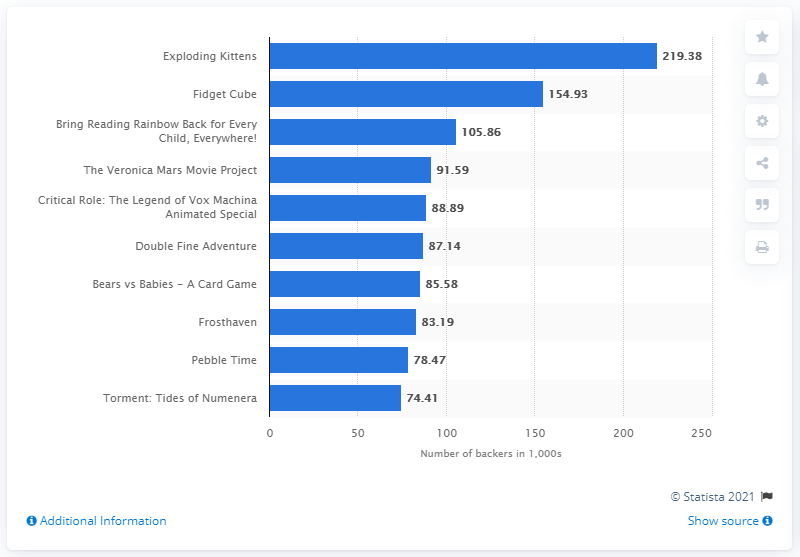List a handful of essential elements in this visual. The card game project named "Exploding Kittens" took first place in February 2015. 